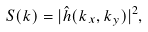Convert formula to latex. <formula><loc_0><loc_0><loc_500><loc_500>S ( k ) = | \hat { h } ( k _ { x } , k _ { y } ) | ^ { 2 } ,</formula> 